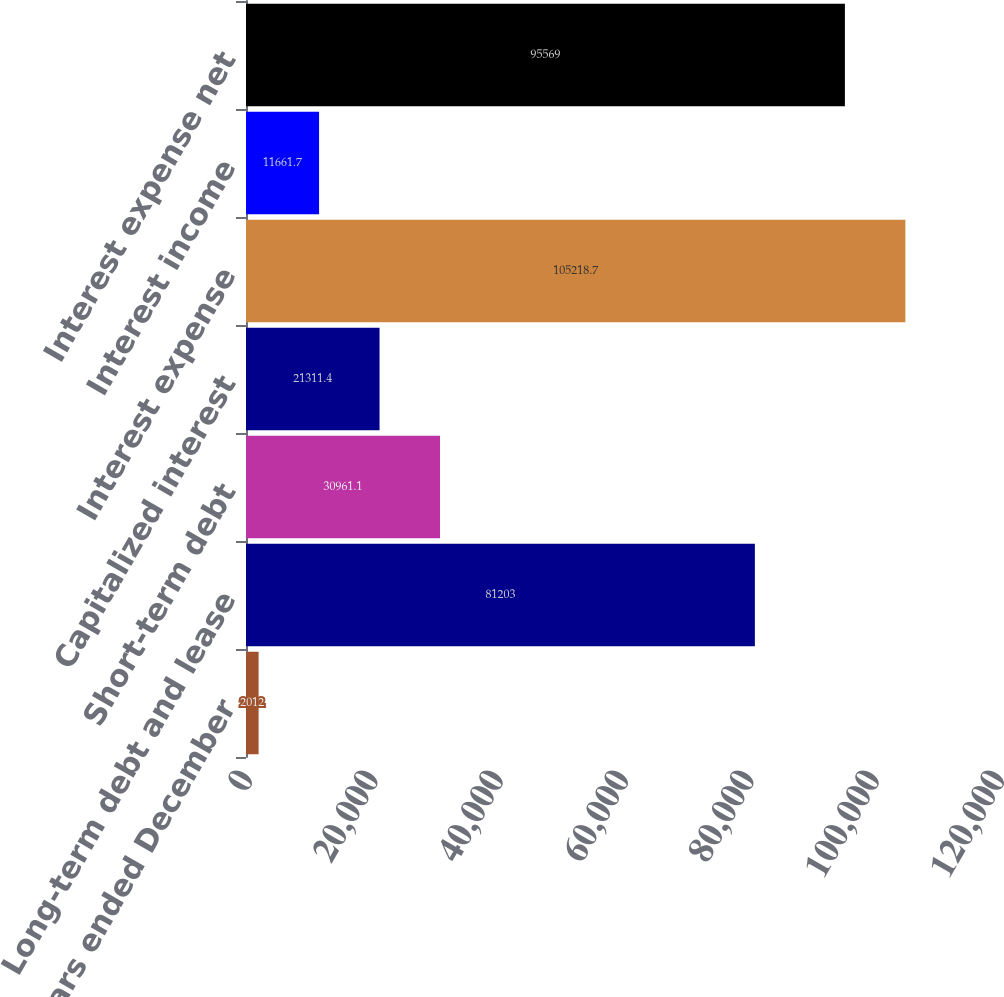<chart> <loc_0><loc_0><loc_500><loc_500><bar_chart><fcel>For the years ended December<fcel>Long-term debt and lease<fcel>Short-term debt<fcel>Capitalized interest<fcel>Interest expense<fcel>Interest income<fcel>Interest expense net<nl><fcel>2012<fcel>81203<fcel>30961.1<fcel>21311.4<fcel>105219<fcel>11661.7<fcel>95569<nl></chart> 